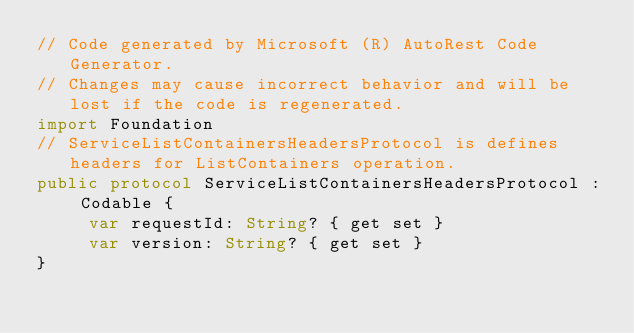<code> <loc_0><loc_0><loc_500><loc_500><_Swift_>// Code generated by Microsoft (R) AutoRest Code Generator.
// Changes may cause incorrect behavior and will be lost if the code is regenerated.
import Foundation
// ServiceListContainersHeadersProtocol is defines headers for ListContainers operation.
public protocol ServiceListContainersHeadersProtocol : Codable {
     var requestId: String? { get set }
     var version: String? { get set }
}
</code> 